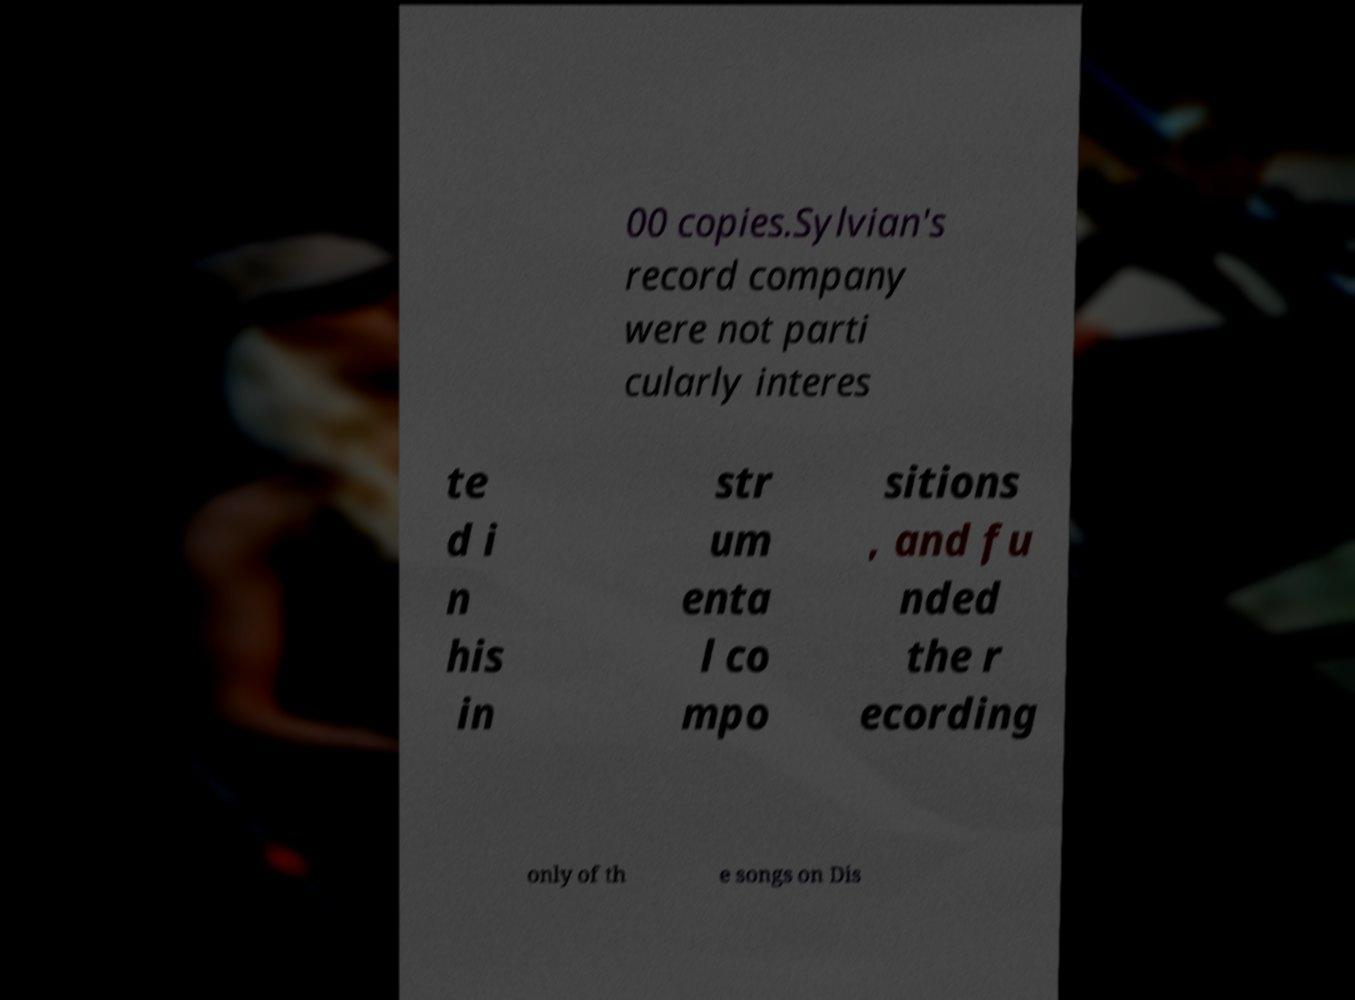Can you read and provide the text displayed in the image?This photo seems to have some interesting text. Can you extract and type it out for me? 00 copies.Sylvian's record company were not parti cularly interes te d i n his in str um enta l co mpo sitions , and fu nded the r ecording only of th e songs on Dis 